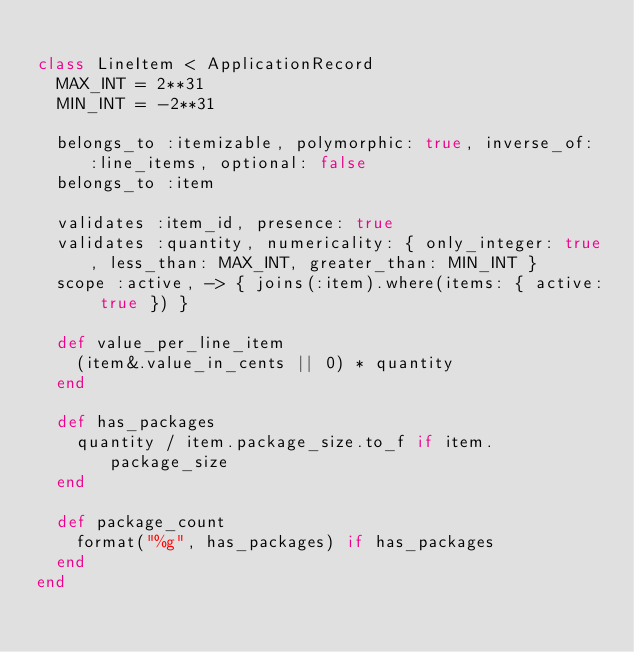<code> <loc_0><loc_0><loc_500><loc_500><_Ruby_>
class LineItem < ApplicationRecord
  MAX_INT = 2**31
  MIN_INT = -2**31

  belongs_to :itemizable, polymorphic: true, inverse_of: :line_items, optional: false
  belongs_to :item

  validates :item_id, presence: true
  validates :quantity, numericality: { only_integer: true, less_than: MAX_INT, greater_than: MIN_INT }
  scope :active, -> { joins(:item).where(items: { active: true }) }

  def value_per_line_item
    (item&.value_in_cents || 0) * quantity
  end

  def has_packages
    quantity / item.package_size.to_f if item.package_size
  end

  def package_count
    format("%g", has_packages) if has_packages
  end
end
</code> 